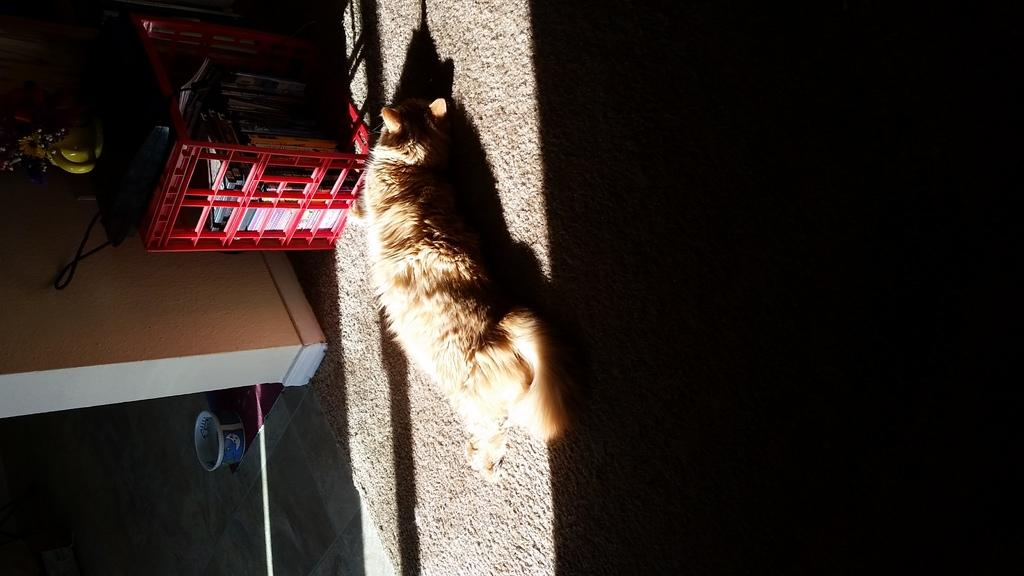What is the main subject of the image? There is an animal on a mat in the image. What can be seen in the red basket in the image? There are books in a red basket in the image. What type of plant is present in the image? There is a flower in the image. What type of fruit is visible in the image? There are bananas in the image. What other objects can be seen in the image? There are other objects in the image, including a bowl on the floor. How would you describe the lighting on the right side of the image? The right side of the image appears to be dark. How many legs does the vest have in the image? There is no vest present in the image, so it is not possible to determine how many legs it might have. 